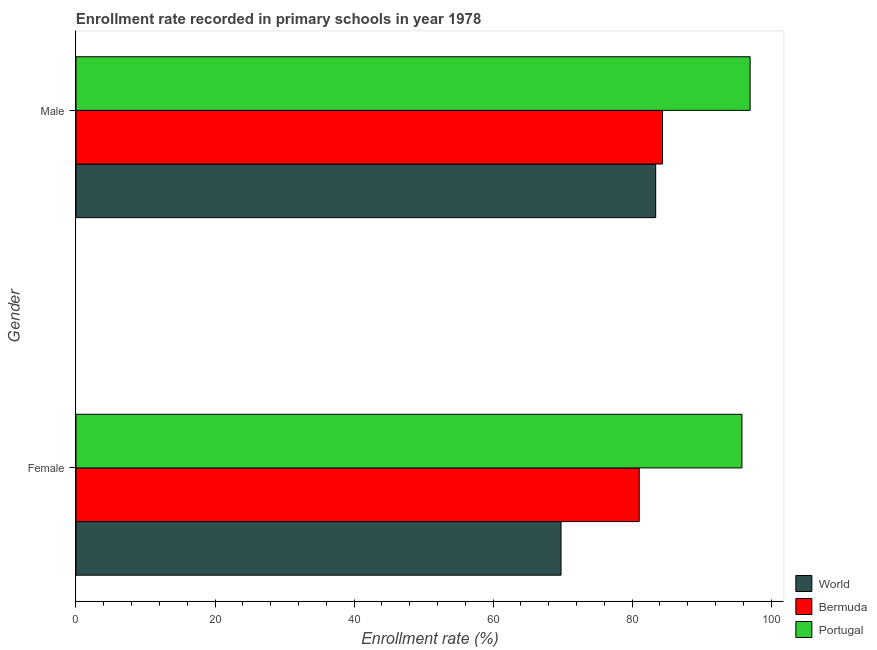How many different coloured bars are there?
Offer a very short reply. 3. How many groups of bars are there?
Keep it short and to the point. 2. Are the number of bars per tick equal to the number of legend labels?
Provide a short and direct response. Yes. Are the number of bars on each tick of the Y-axis equal?
Provide a short and direct response. Yes. What is the enrollment rate of female students in Bermuda?
Make the answer very short. 81.03. Across all countries, what is the maximum enrollment rate of male students?
Provide a succinct answer. 96.99. Across all countries, what is the minimum enrollment rate of female students?
Offer a very short reply. 69.78. What is the total enrollment rate of male students in the graph?
Offer a terse response. 264.77. What is the difference between the enrollment rate of female students in World and that in Portugal?
Provide a short and direct response. -26.03. What is the difference between the enrollment rate of female students in Bermuda and the enrollment rate of male students in World?
Offer a terse response. -2.37. What is the average enrollment rate of male students per country?
Keep it short and to the point. 88.26. What is the difference between the enrollment rate of female students and enrollment rate of male students in World?
Keep it short and to the point. -13.62. What is the ratio of the enrollment rate of male students in Bermuda to that in Portugal?
Your response must be concise. 0.87. Is the enrollment rate of female students in Portugal less than that in Bermuda?
Provide a short and direct response. No. In how many countries, is the enrollment rate of female students greater than the average enrollment rate of female students taken over all countries?
Keep it short and to the point. 1. What does the 3rd bar from the top in Female represents?
Ensure brevity in your answer.  World. What does the 2nd bar from the bottom in Male represents?
Give a very brief answer. Bermuda. Are all the bars in the graph horizontal?
Provide a short and direct response. Yes. Where does the legend appear in the graph?
Your response must be concise. Bottom right. How are the legend labels stacked?
Provide a short and direct response. Vertical. What is the title of the graph?
Your answer should be very brief. Enrollment rate recorded in primary schools in year 1978. Does "Egypt, Arab Rep." appear as one of the legend labels in the graph?
Your answer should be compact. No. What is the label or title of the X-axis?
Provide a succinct answer. Enrollment rate (%). What is the Enrollment rate (%) in World in Female?
Your answer should be very brief. 69.78. What is the Enrollment rate (%) in Bermuda in Female?
Provide a short and direct response. 81.03. What is the Enrollment rate (%) in Portugal in Female?
Provide a succinct answer. 95.81. What is the Enrollment rate (%) of World in Male?
Make the answer very short. 83.4. What is the Enrollment rate (%) in Bermuda in Male?
Ensure brevity in your answer.  84.38. What is the Enrollment rate (%) of Portugal in Male?
Your answer should be very brief. 96.99. Across all Gender, what is the maximum Enrollment rate (%) of World?
Offer a terse response. 83.4. Across all Gender, what is the maximum Enrollment rate (%) in Bermuda?
Make the answer very short. 84.38. Across all Gender, what is the maximum Enrollment rate (%) in Portugal?
Offer a terse response. 96.99. Across all Gender, what is the minimum Enrollment rate (%) in World?
Your response must be concise. 69.78. Across all Gender, what is the minimum Enrollment rate (%) of Bermuda?
Offer a terse response. 81.03. Across all Gender, what is the minimum Enrollment rate (%) of Portugal?
Keep it short and to the point. 95.81. What is the total Enrollment rate (%) in World in the graph?
Give a very brief answer. 153.18. What is the total Enrollment rate (%) in Bermuda in the graph?
Your answer should be compact. 165.42. What is the total Enrollment rate (%) in Portugal in the graph?
Your response must be concise. 192.8. What is the difference between the Enrollment rate (%) of World in Female and that in Male?
Provide a short and direct response. -13.62. What is the difference between the Enrollment rate (%) in Bermuda in Female and that in Male?
Offer a terse response. -3.35. What is the difference between the Enrollment rate (%) in Portugal in Female and that in Male?
Ensure brevity in your answer.  -1.18. What is the difference between the Enrollment rate (%) of World in Female and the Enrollment rate (%) of Bermuda in Male?
Offer a terse response. -14.6. What is the difference between the Enrollment rate (%) of World in Female and the Enrollment rate (%) of Portugal in Male?
Ensure brevity in your answer.  -27.2. What is the difference between the Enrollment rate (%) of Bermuda in Female and the Enrollment rate (%) of Portugal in Male?
Make the answer very short. -15.95. What is the average Enrollment rate (%) in World per Gender?
Give a very brief answer. 76.59. What is the average Enrollment rate (%) of Bermuda per Gender?
Keep it short and to the point. 82.71. What is the average Enrollment rate (%) of Portugal per Gender?
Your response must be concise. 96.4. What is the difference between the Enrollment rate (%) in World and Enrollment rate (%) in Bermuda in Female?
Ensure brevity in your answer.  -11.25. What is the difference between the Enrollment rate (%) in World and Enrollment rate (%) in Portugal in Female?
Your answer should be very brief. -26.03. What is the difference between the Enrollment rate (%) in Bermuda and Enrollment rate (%) in Portugal in Female?
Your answer should be compact. -14.78. What is the difference between the Enrollment rate (%) of World and Enrollment rate (%) of Bermuda in Male?
Provide a succinct answer. -0.98. What is the difference between the Enrollment rate (%) of World and Enrollment rate (%) of Portugal in Male?
Offer a very short reply. -13.59. What is the difference between the Enrollment rate (%) in Bermuda and Enrollment rate (%) in Portugal in Male?
Offer a terse response. -12.6. What is the ratio of the Enrollment rate (%) of World in Female to that in Male?
Ensure brevity in your answer.  0.84. What is the ratio of the Enrollment rate (%) in Bermuda in Female to that in Male?
Provide a succinct answer. 0.96. What is the ratio of the Enrollment rate (%) of Portugal in Female to that in Male?
Provide a short and direct response. 0.99. What is the difference between the highest and the second highest Enrollment rate (%) in World?
Offer a terse response. 13.62. What is the difference between the highest and the second highest Enrollment rate (%) of Bermuda?
Give a very brief answer. 3.35. What is the difference between the highest and the second highest Enrollment rate (%) of Portugal?
Provide a succinct answer. 1.18. What is the difference between the highest and the lowest Enrollment rate (%) in World?
Your answer should be compact. 13.62. What is the difference between the highest and the lowest Enrollment rate (%) of Bermuda?
Your response must be concise. 3.35. What is the difference between the highest and the lowest Enrollment rate (%) of Portugal?
Offer a very short reply. 1.18. 